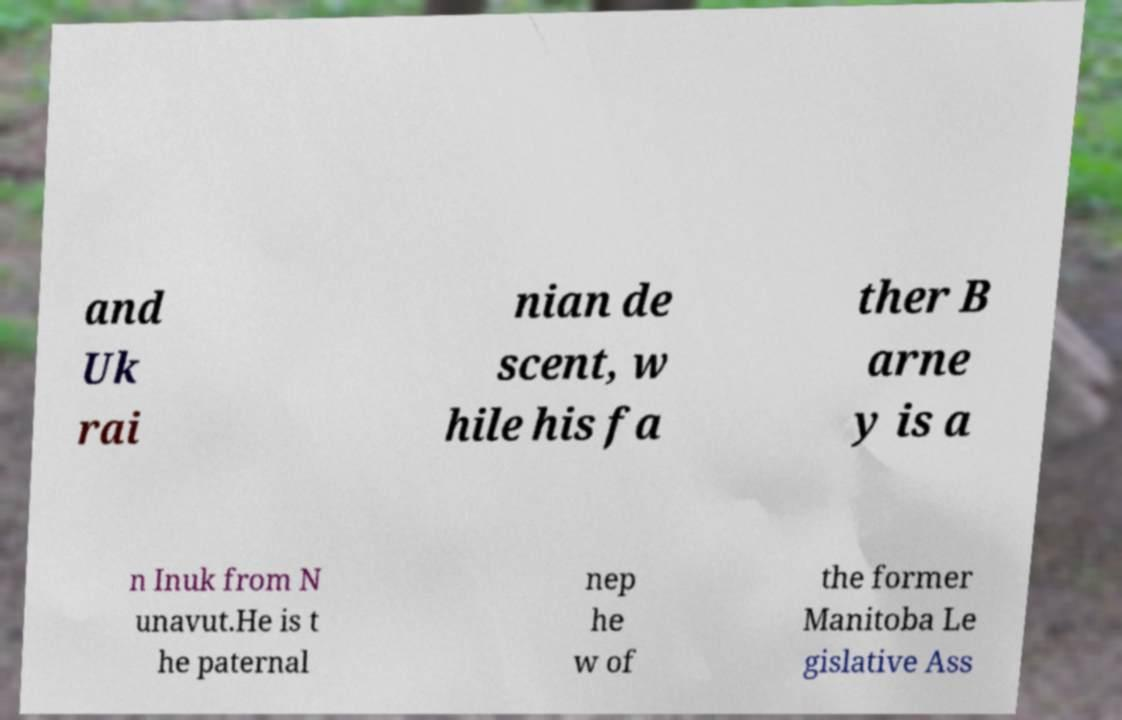Please read and relay the text visible in this image. What does it say? and Uk rai nian de scent, w hile his fa ther B arne y is a n Inuk from N unavut.He is t he paternal nep he w of the former Manitoba Le gislative Ass 